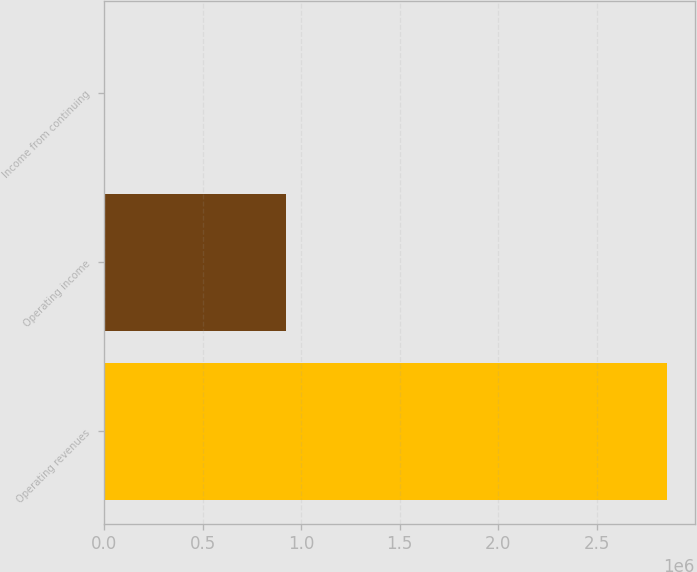<chart> <loc_0><loc_0><loc_500><loc_500><bar_chart><fcel>Operating revenues<fcel>Operating income<fcel>Income from continuing<nl><fcel>2.85393e+06<fcel>924104<fcel>2.1<nl></chart> 